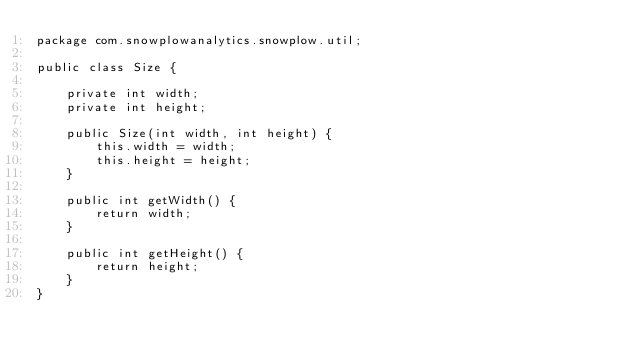<code> <loc_0><loc_0><loc_500><loc_500><_Java_>package com.snowplowanalytics.snowplow.util;

public class Size {

    private int width;
    private int height;

    public Size(int width, int height) {
        this.width = width;
        this.height = height;
    }

    public int getWidth() {
        return width;
    }

    public int getHeight() {
        return height;
    }
}
</code> 